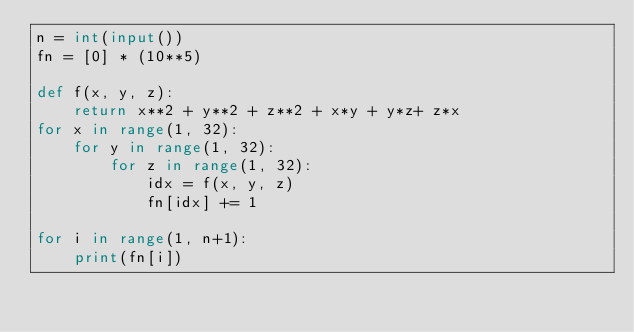Convert code to text. <code><loc_0><loc_0><loc_500><loc_500><_Python_>n = int(input())
fn = [0] * (10**5)

def f(x, y, z):
    return x**2 + y**2 + z**2 + x*y + y*z+ z*x 
for x in range(1, 32):
    for y in range(1, 32):
        for z in range(1, 32):
            idx = f(x, y, z)
            fn[idx] += 1

for i in range(1, n+1):
    print(fn[i])

</code> 